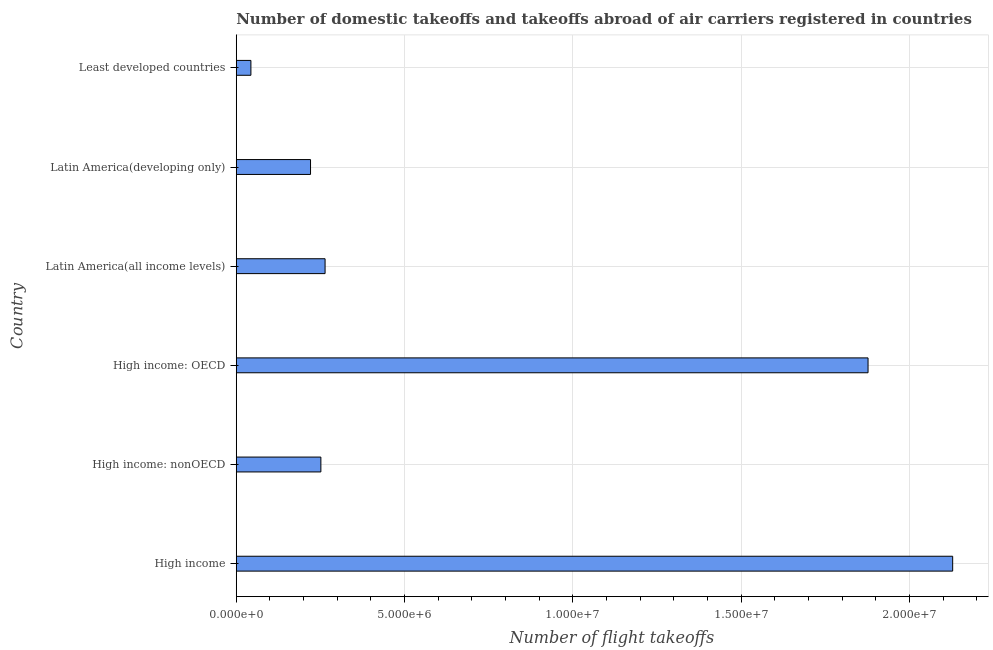What is the title of the graph?
Make the answer very short. Number of domestic takeoffs and takeoffs abroad of air carriers registered in countries. What is the label or title of the X-axis?
Keep it short and to the point. Number of flight takeoffs. What is the number of flight takeoffs in Least developed countries?
Provide a succinct answer. 4.35e+05. Across all countries, what is the maximum number of flight takeoffs?
Provide a short and direct response. 2.13e+07. Across all countries, what is the minimum number of flight takeoffs?
Your answer should be very brief. 4.35e+05. In which country was the number of flight takeoffs minimum?
Ensure brevity in your answer.  Least developed countries. What is the sum of the number of flight takeoffs?
Offer a terse response. 4.79e+07. What is the difference between the number of flight takeoffs in High income and High income: OECD?
Ensure brevity in your answer.  2.51e+06. What is the average number of flight takeoffs per country?
Ensure brevity in your answer.  7.98e+06. What is the median number of flight takeoffs?
Provide a short and direct response. 2.58e+06. What is the ratio of the number of flight takeoffs in High income to that in High income: OECD?
Give a very brief answer. 1.13. What is the difference between the highest and the second highest number of flight takeoffs?
Your response must be concise. 2.51e+06. What is the difference between the highest and the lowest number of flight takeoffs?
Your answer should be compact. 2.09e+07. Are the values on the major ticks of X-axis written in scientific E-notation?
Offer a very short reply. Yes. What is the Number of flight takeoffs in High income?
Keep it short and to the point. 2.13e+07. What is the Number of flight takeoffs of High income: nonOECD?
Your answer should be compact. 2.51e+06. What is the Number of flight takeoffs of High income: OECD?
Offer a terse response. 1.88e+07. What is the Number of flight takeoffs in Latin America(all income levels)?
Make the answer very short. 2.64e+06. What is the Number of flight takeoffs in Latin America(developing only)?
Offer a terse response. 2.21e+06. What is the Number of flight takeoffs in Least developed countries?
Keep it short and to the point. 4.35e+05. What is the difference between the Number of flight takeoffs in High income and High income: nonOECD?
Make the answer very short. 1.88e+07. What is the difference between the Number of flight takeoffs in High income and High income: OECD?
Offer a terse response. 2.51e+06. What is the difference between the Number of flight takeoffs in High income and Latin America(all income levels)?
Provide a short and direct response. 1.86e+07. What is the difference between the Number of flight takeoffs in High income and Latin America(developing only)?
Make the answer very short. 1.91e+07. What is the difference between the Number of flight takeoffs in High income and Least developed countries?
Provide a succinct answer. 2.09e+07. What is the difference between the Number of flight takeoffs in High income: nonOECD and High income: OECD?
Your answer should be very brief. -1.63e+07. What is the difference between the Number of flight takeoffs in High income: nonOECD and Latin America(all income levels)?
Make the answer very short. -1.25e+05. What is the difference between the Number of flight takeoffs in High income: nonOECD and Latin America(developing only)?
Offer a terse response. 3.07e+05. What is the difference between the Number of flight takeoffs in High income: nonOECD and Least developed countries?
Provide a short and direct response. 2.08e+06. What is the difference between the Number of flight takeoffs in High income: OECD and Latin America(all income levels)?
Give a very brief answer. 1.61e+07. What is the difference between the Number of flight takeoffs in High income: OECD and Latin America(developing only)?
Ensure brevity in your answer.  1.66e+07. What is the difference between the Number of flight takeoffs in High income: OECD and Least developed countries?
Your answer should be compact. 1.83e+07. What is the difference between the Number of flight takeoffs in Latin America(all income levels) and Latin America(developing only)?
Provide a short and direct response. 4.32e+05. What is the difference between the Number of flight takeoffs in Latin America(all income levels) and Least developed countries?
Keep it short and to the point. 2.20e+06. What is the difference between the Number of flight takeoffs in Latin America(developing only) and Least developed countries?
Make the answer very short. 1.77e+06. What is the ratio of the Number of flight takeoffs in High income to that in High income: nonOECD?
Ensure brevity in your answer.  8.47. What is the ratio of the Number of flight takeoffs in High income to that in High income: OECD?
Ensure brevity in your answer.  1.13. What is the ratio of the Number of flight takeoffs in High income to that in Latin America(all income levels)?
Offer a terse response. 8.07. What is the ratio of the Number of flight takeoffs in High income to that in Latin America(developing only)?
Keep it short and to the point. 9.64. What is the ratio of the Number of flight takeoffs in High income to that in Least developed countries?
Your response must be concise. 48.91. What is the ratio of the Number of flight takeoffs in High income: nonOECD to that in High income: OECD?
Ensure brevity in your answer.  0.13. What is the ratio of the Number of flight takeoffs in High income: nonOECD to that in Latin America(all income levels)?
Your response must be concise. 0.95. What is the ratio of the Number of flight takeoffs in High income: nonOECD to that in Latin America(developing only)?
Keep it short and to the point. 1.14. What is the ratio of the Number of flight takeoffs in High income: nonOECD to that in Least developed countries?
Give a very brief answer. 5.78. What is the ratio of the Number of flight takeoffs in High income: OECD to that in Latin America(all income levels)?
Ensure brevity in your answer.  7.11. What is the ratio of the Number of flight takeoffs in High income: OECD to that in Latin America(developing only)?
Ensure brevity in your answer.  8.51. What is the ratio of the Number of flight takeoffs in High income: OECD to that in Least developed countries?
Make the answer very short. 43.13. What is the ratio of the Number of flight takeoffs in Latin America(all income levels) to that in Latin America(developing only)?
Keep it short and to the point. 1.2. What is the ratio of the Number of flight takeoffs in Latin America(all income levels) to that in Least developed countries?
Offer a very short reply. 6.06. What is the ratio of the Number of flight takeoffs in Latin America(developing only) to that in Least developed countries?
Offer a very short reply. 5.07. 